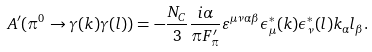Convert formula to latex. <formula><loc_0><loc_0><loc_500><loc_500>A ^ { \prime } ( \pi ^ { 0 } \rightarrow \gamma ( k ) \gamma ( l ) ) = - \frac { N _ { C } } { 3 } \frac { i \alpha } { \pi F ^ { \prime } _ { \pi } } \varepsilon ^ { \mu \nu \alpha \beta } \epsilon ^ { * } _ { \mu } ( k ) \epsilon ^ { * } _ { \nu } ( l ) k _ { \alpha } l _ { \beta } .</formula> 